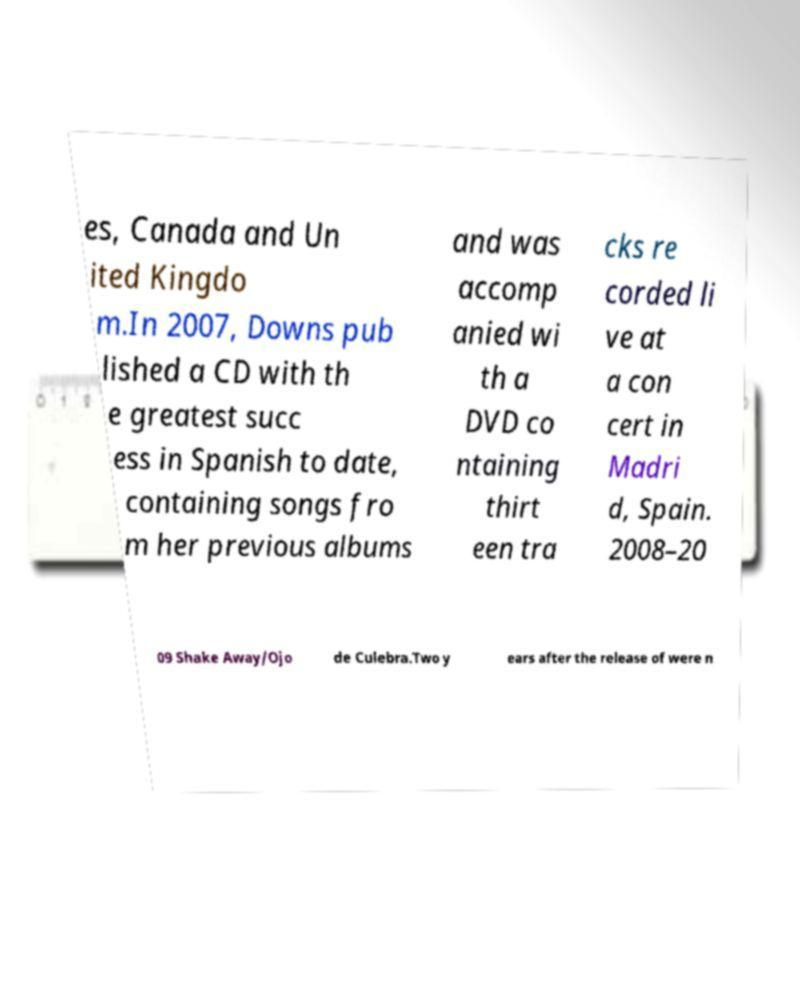There's text embedded in this image that I need extracted. Can you transcribe it verbatim? es, Canada and Un ited Kingdo m.In 2007, Downs pub lished a CD with th e greatest succ ess in Spanish to date, containing songs fro m her previous albums and was accomp anied wi th a DVD co ntaining thirt een tra cks re corded li ve at a con cert in Madri d, Spain. 2008–20 09 Shake Away/Ojo de Culebra.Two y ears after the release of were n 